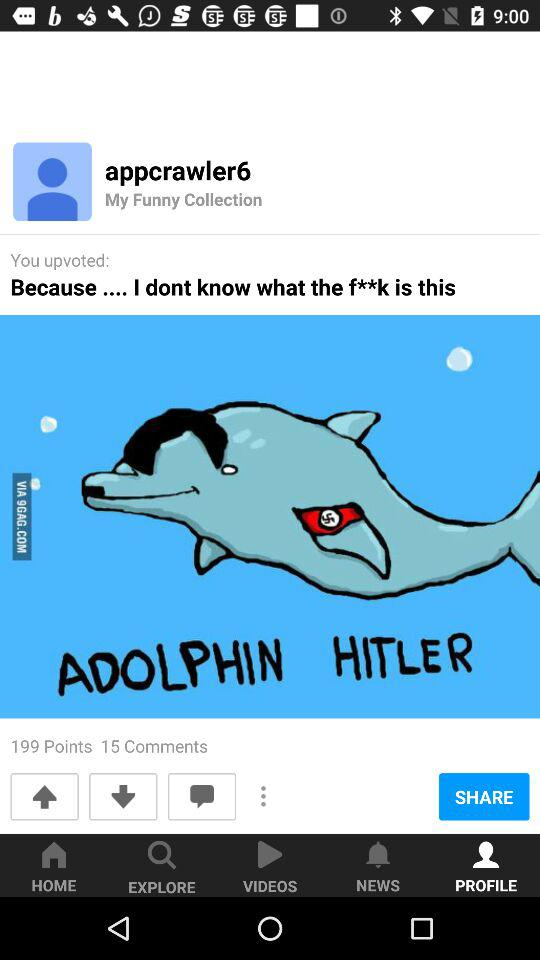How many more points than comments does the post have?
Answer the question using a single word or phrase. 184 